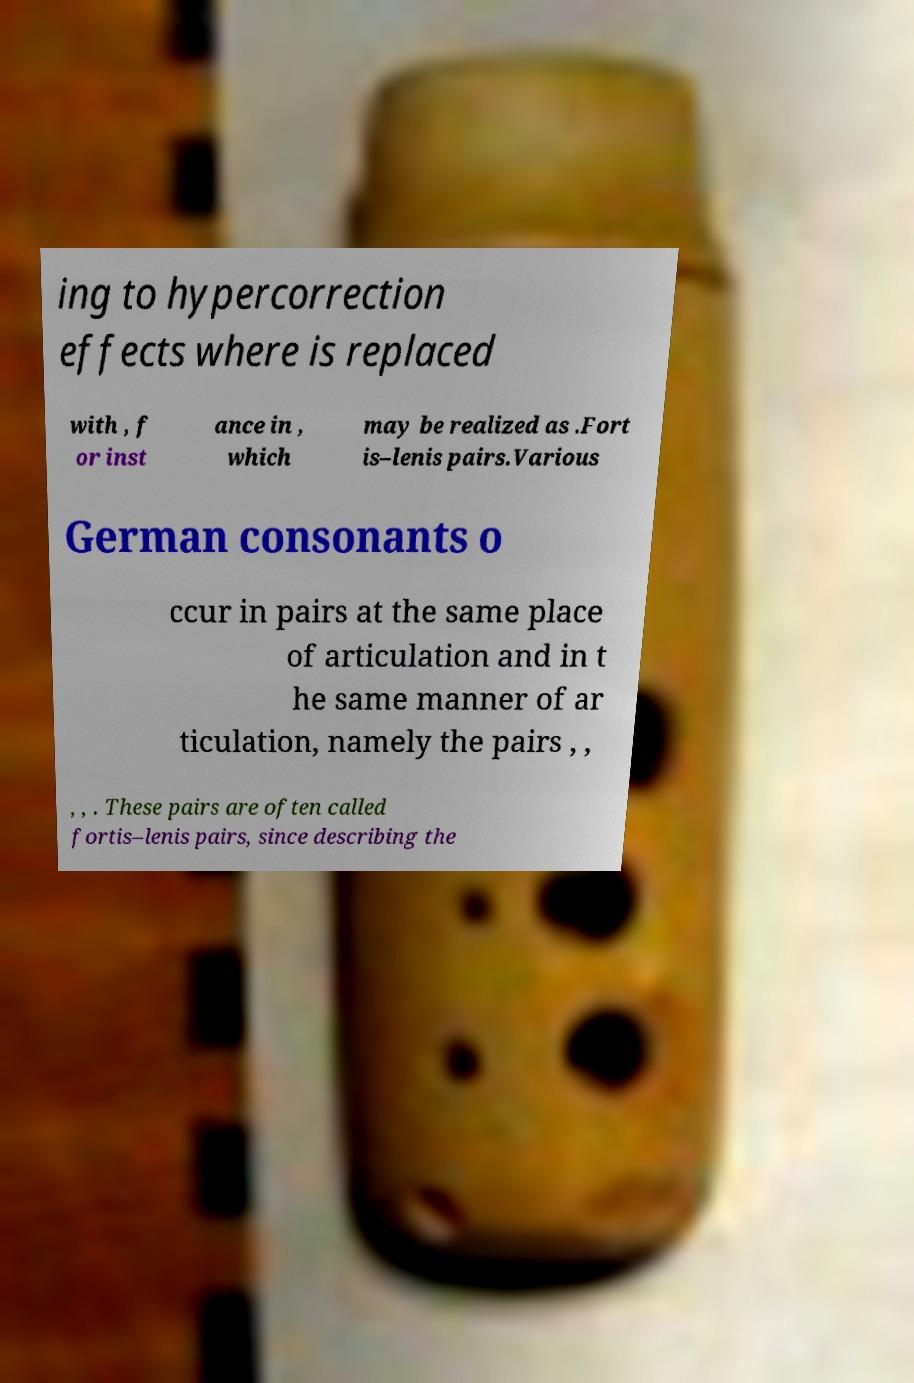I need the written content from this picture converted into text. Can you do that? ing to hypercorrection effects where is replaced with , f or inst ance in , which may be realized as .Fort is–lenis pairs.Various German consonants o ccur in pairs at the same place of articulation and in t he same manner of ar ticulation, namely the pairs , , , , . These pairs are often called fortis–lenis pairs, since describing the 